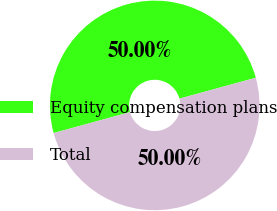Convert chart. <chart><loc_0><loc_0><loc_500><loc_500><pie_chart><fcel>Equity compensation plans<fcel>Total<nl><fcel>50.0%<fcel>50.0%<nl></chart> 